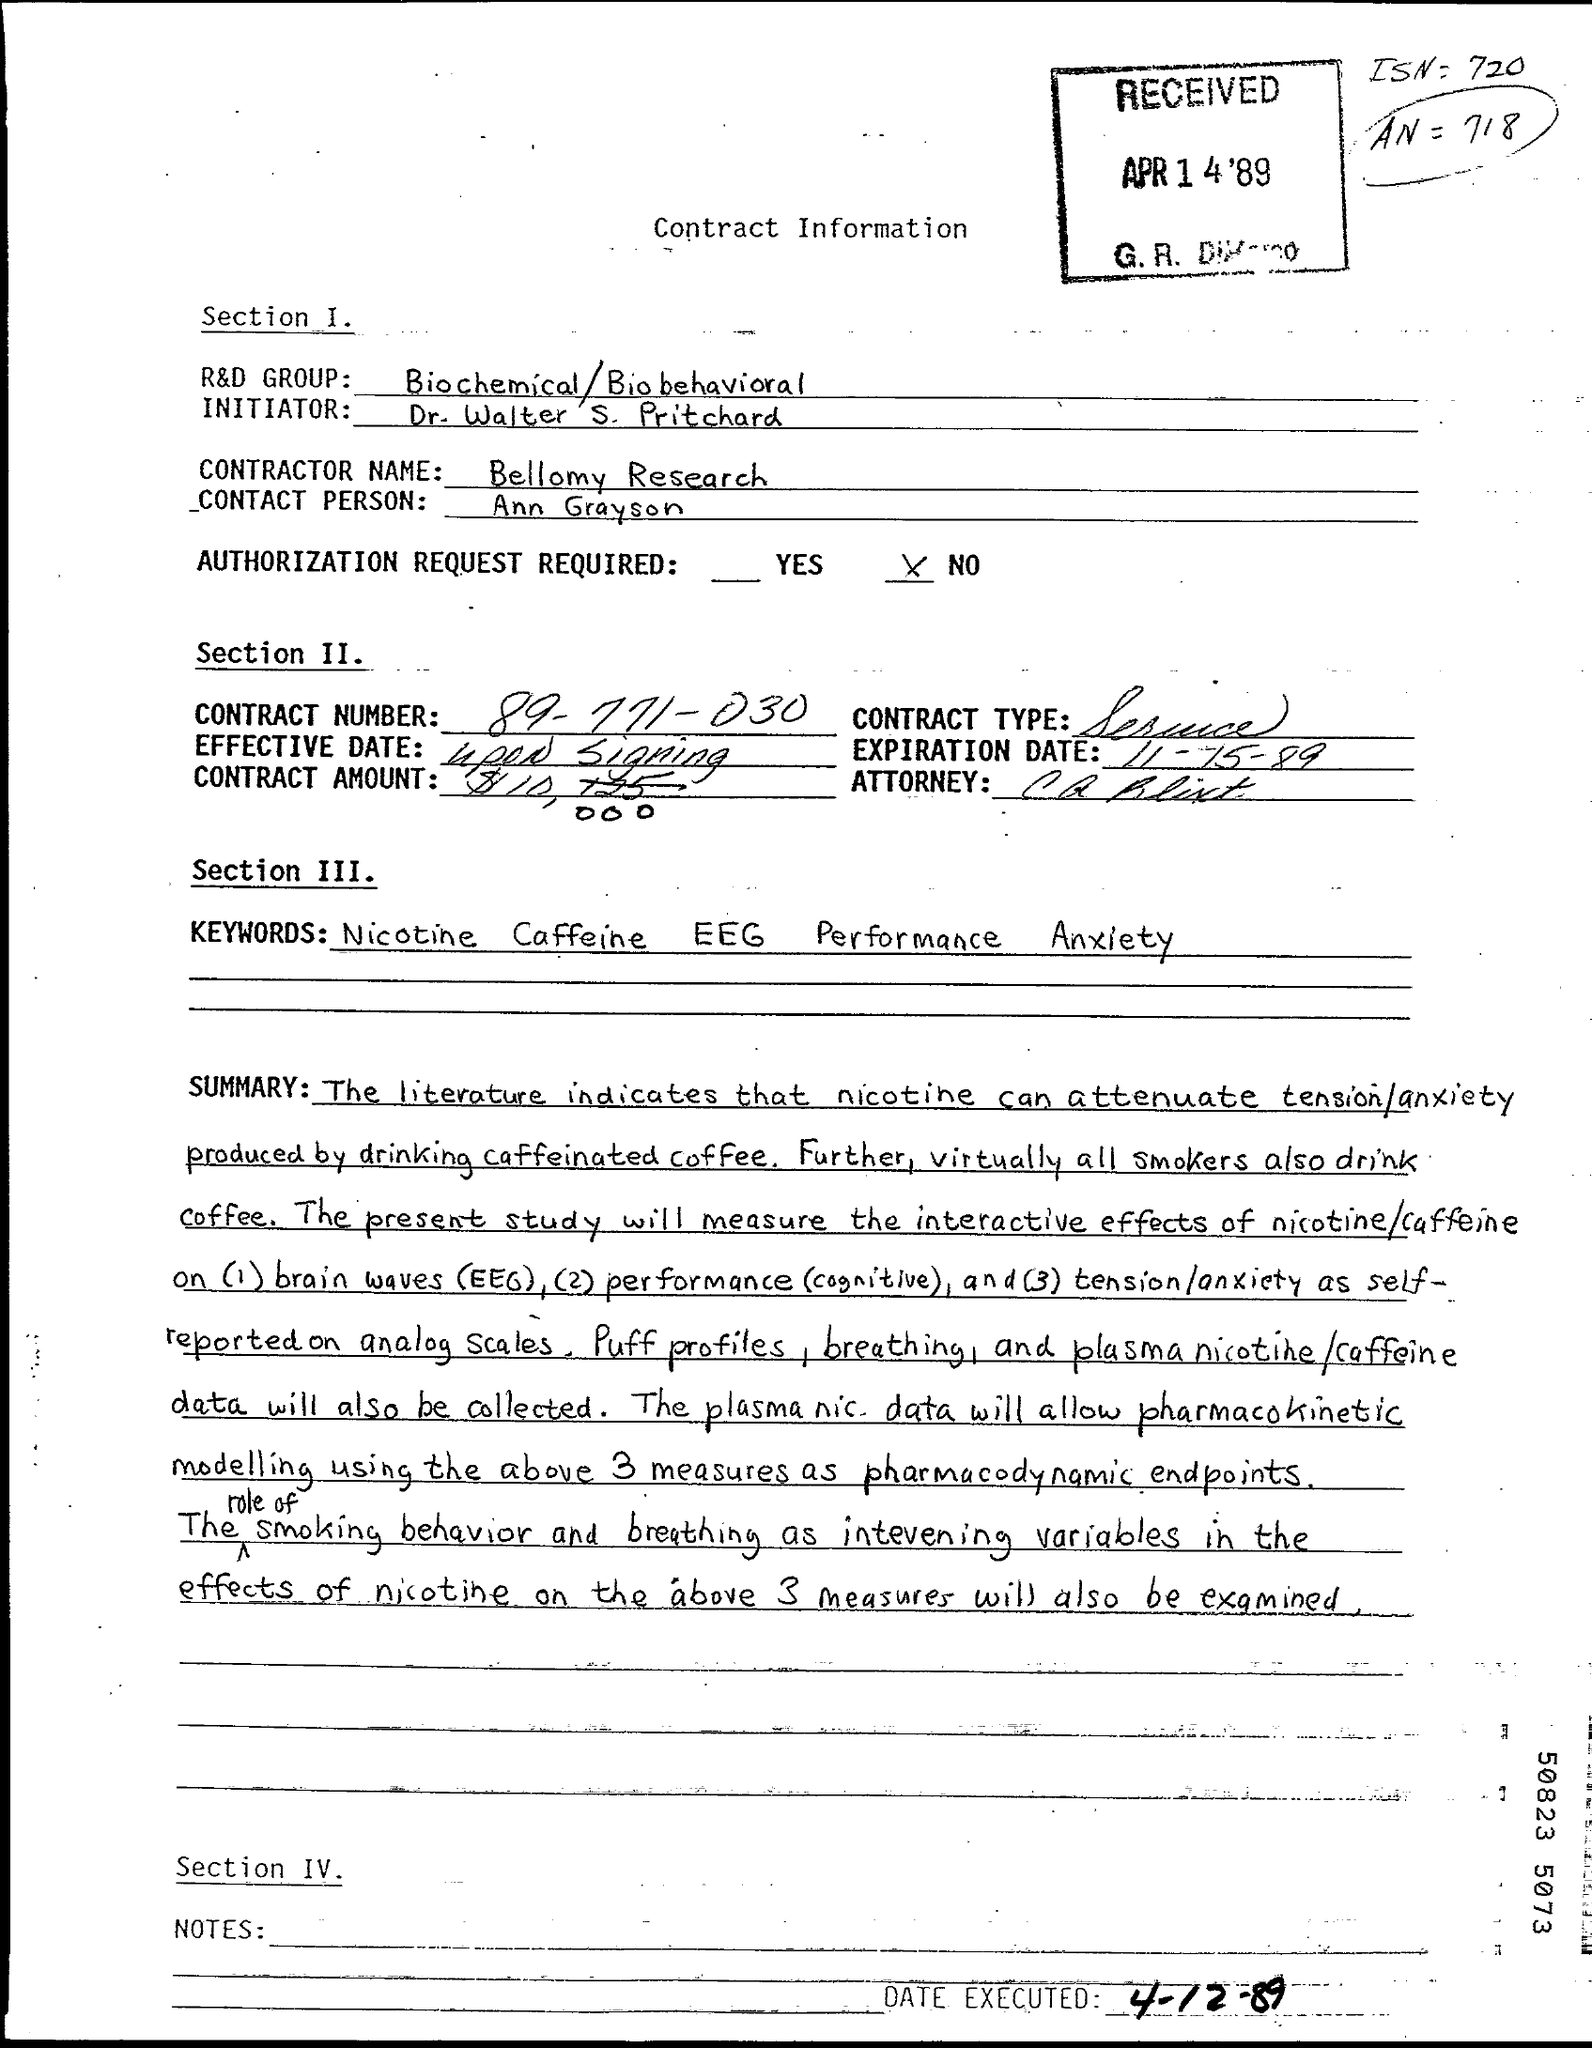Which R&D Group is mentioned in this dcoument?
Make the answer very short. Biochemical/Biobehavioral. Who is the Initiator as per the document?
Offer a very short reply. Dr. Walter S. Pritchard. What is the Contractor Name given in the document?
Make the answer very short. Bellomy research. Who is the Contact person as per the document?
Provide a short and direct response. Ann Grayson. What is the Contract Number given?
Keep it short and to the point. 89-771-030. What is the Expiration date mentioned in the document?
Give a very brief answer. 11-15-89. What is the Contract Type mentioned in this document?
Make the answer very short. Service. 